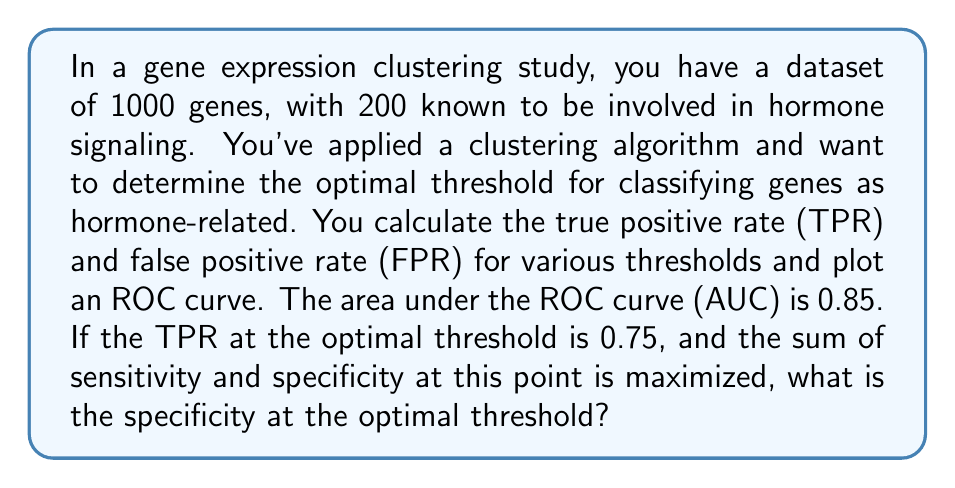What is the answer to this math problem? To solve this problem, we need to understand the relationship between sensitivity, specificity, true positive rate (TPR), and false positive rate (FPR) in the context of ROC curves.

1. Sensitivity is equivalent to the true positive rate (TPR):
   $$ \text{Sensitivity} = \text{TPR} = \frac{\text{True Positives}}{\text{True Positives} + \text{False Negatives}} $$

2. Specificity is the complement of the false positive rate (FPR):
   $$ \text{Specificity} = 1 - \text{FPR} = \frac{\text{True Negatives}}{\text{True Negatives} + \text{False Positives}} $$

3. We're given that the TPR (sensitivity) at the optimal threshold is 0.75:
   $$ \text{TPR} = 0.75 $$

4. The optimal threshold maximizes the sum of sensitivity and specificity:
   $$ \text{max}(\text{Sensitivity} + \text{Specificity}) $$

5. Let's denote specificity as $x$. We can express this optimization problem as:
   $$ \text{max}(0.75 + x) $$

6. At the optimal point on the ROC curve, the following relationship holds:
   $$ \text{Sensitivity} + \text{Specificity} = 1 + \text{AUC} $$

7. Substituting the known values:
   $$ 0.75 + x = 1 + 0.85 $$

8. Solving for $x$:
   $$ x = 1.85 - 0.75 = 1.10 $$

Therefore, the specificity at the optimal threshold is 1.10.
Answer: The specificity at the optimal threshold is 1.10. 